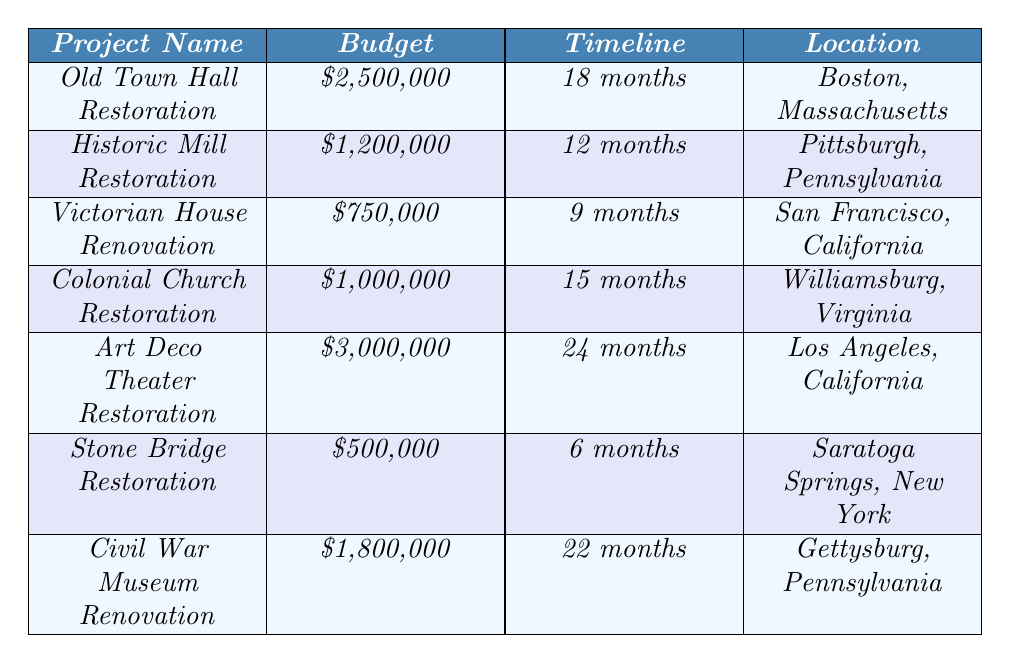What is the budget for the Old Town Hall Restoration project? The budget for the Old Town Hall Restoration is listed directly in the table. It states the amount as $2,500,000.
Answer: $2,500,000 How long is the timeline for the Victorian House Renovation? The timeline for the Victorian House Renovation can be found in the corresponding row of the table, which states it is 9 months.
Answer: 9 months Is the budget for the Civil War Museum Renovation greater than that for the Colonial Church Restoration? The budget for the Civil War Museum Renovation is $1,800,000, while the Colonial Church Restoration is $1,000,000. Since 1,800,000 is greater than 1,000,000, the statement is true.
Answer: Yes What is the total budget for the Historic Mill Restoration and the Stone Bridge Restoration combined? The budget for the Historic Mill Restoration is $1,200,000 and for the Stone Bridge Restoration is $500,000. Adding them together gives $1,200,000 + $500,000 = $1,700,000.
Answer: $1,700,000 Which restoration project has the longest timeline, and what is that timeline? The table indicates the Art Deco Theater Restoration has the longest timeline of 24 months. By comparing all projects, this is confirmed as the longest duration.
Answer: Art Deco Theater Restoration, 24 months Is the location of the Colonial Church Restoration in Virginia? The table indicates that the location for Colonial Church Restoration is Williamsburg, Virginia. Thus, the statement is true.
Answer: Yes How does the budget of the Stone Bridge Restoration compare to the average budget of all projects listed? The budgets are as follows: $2,500,000, $1,200,000, $750,000, $1,000,000, $3,000,000, $500,000, and $1,800,000. Summing these gives $10,750,000, and dividing by 7 projects gives an average of $1,535,714. The Stone Bridge Restoration budget is $500,000, which is less than $1,535,714.
Answer: Less than average What are the locations of the projects with budgets greater than $1,000,000? The projects with budgets greater than $1,000,000 are: Old Town Hall Restoration ($2,500,000) in Boston, Art Deco Theater Restoration ($3,000,000) in Los Angeles, Civil War Museum Renovation ($1,800,000) in Gettysburg, and Colonial Church Restoration ($1,000,000) in Williamsburg. The locations are therefore Boston, Los Angeles, Gettysburg, and Williamsburg.
Answer: Boston, Los Angeles, Gettysburg, Williamsburg 